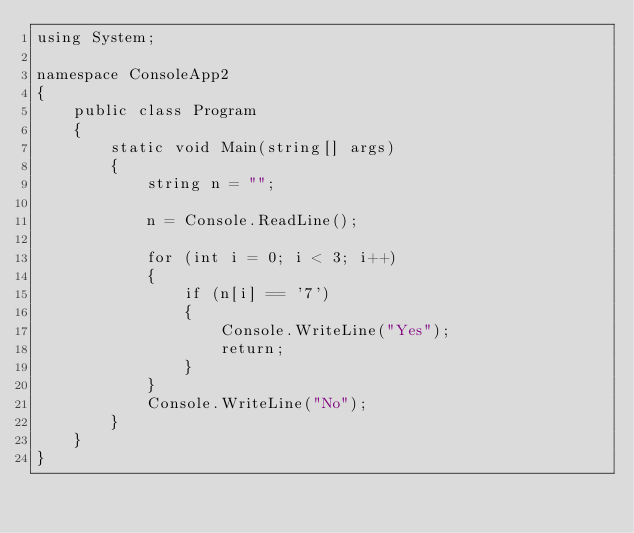Convert code to text. <code><loc_0><loc_0><loc_500><loc_500><_C#_>using System;

namespace ConsoleApp2
{
    public class Program
    {
        static void Main(string[] args)
        {
            string n = "";

            n = Console.ReadLine();

            for (int i = 0; i < 3; i++)
            {
                if (n[i] == '7')
                {
                    Console.WriteLine("Yes");
                    return;
                }
            }
            Console.WriteLine("No");
        }
    }
}
</code> 